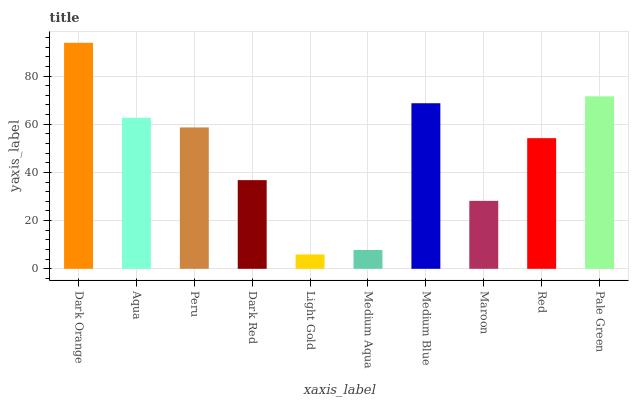Is Light Gold the minimum?
Answer yes or no. Yes. Is Dark Orange the maximum?
Answer yes or no. Yes. Is Aqua the minimum?
Answer yes or no. No. Is Aqua the maximum?
Answer yes or no. No. Is Dark Orange greater than Aqua?
Answer yes or no. Yes. Is Aqua less than Dark Orange?
Answer yes or no. Yes. Is Aqua greater than Dark Orange?
Answer yes or no. No. Is Dark Orange less than Aqua?
Answer yes or no. No. Is Peru the high median?
Answer yes or no. Yes. Is Red the low median?
Answer yes or no. Yes. Is Light Gold the high median?
Answer yes or no. No. Is Medium Aqua the low median?
Answer yes or no. No. 